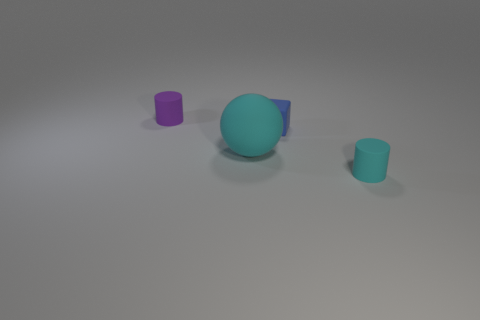Add 1 tiny red spheres. How many objects exist? 5 Subtract all blue matte things. Subtract all large cyan matte balls. How many objects are left? 2 Add 3 small rubber cubes. How many small rubber cubes are left? 4 Add 3 tiny brown rubber balls. How many tiny brown rubber balls exist? 3 Subtract all purple cylinders. How many cylinders are left? 1 Subtract 0 brown cylinders. How many objects are left? 4 Subtract 1 cylinders. How many cylinders are left? 1 Subtract all yellow blocks. Subtract all cyan spheres. How many blocks are left? 1 Subtract all red cubes. How many cyan cylinders are left? 1 